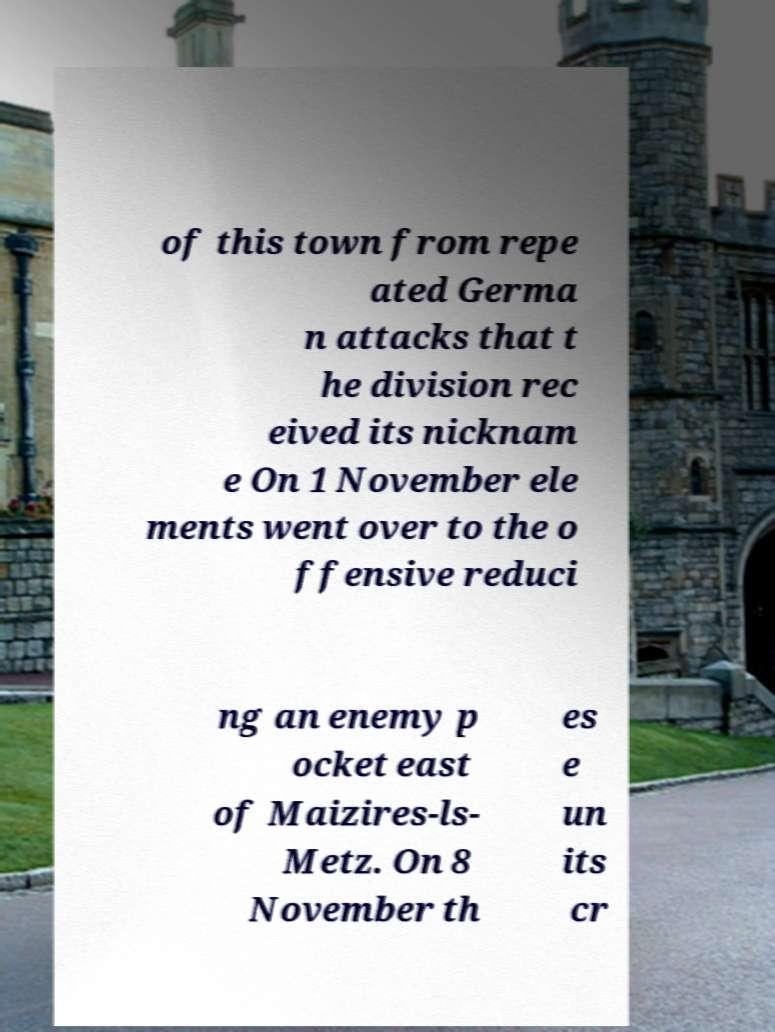Can you read and provide the text displayed in the image?This photo seems to have some interesting text. Can you extract and type it out for me? of this town from repe ated Germa n attacks that t he division rec eived its nicknam e On 1 November ele ments went over to the o ffensive reduci ng an enemy p ocket east of Maizires-ls- Metz. On 8 November th es e un its cr 